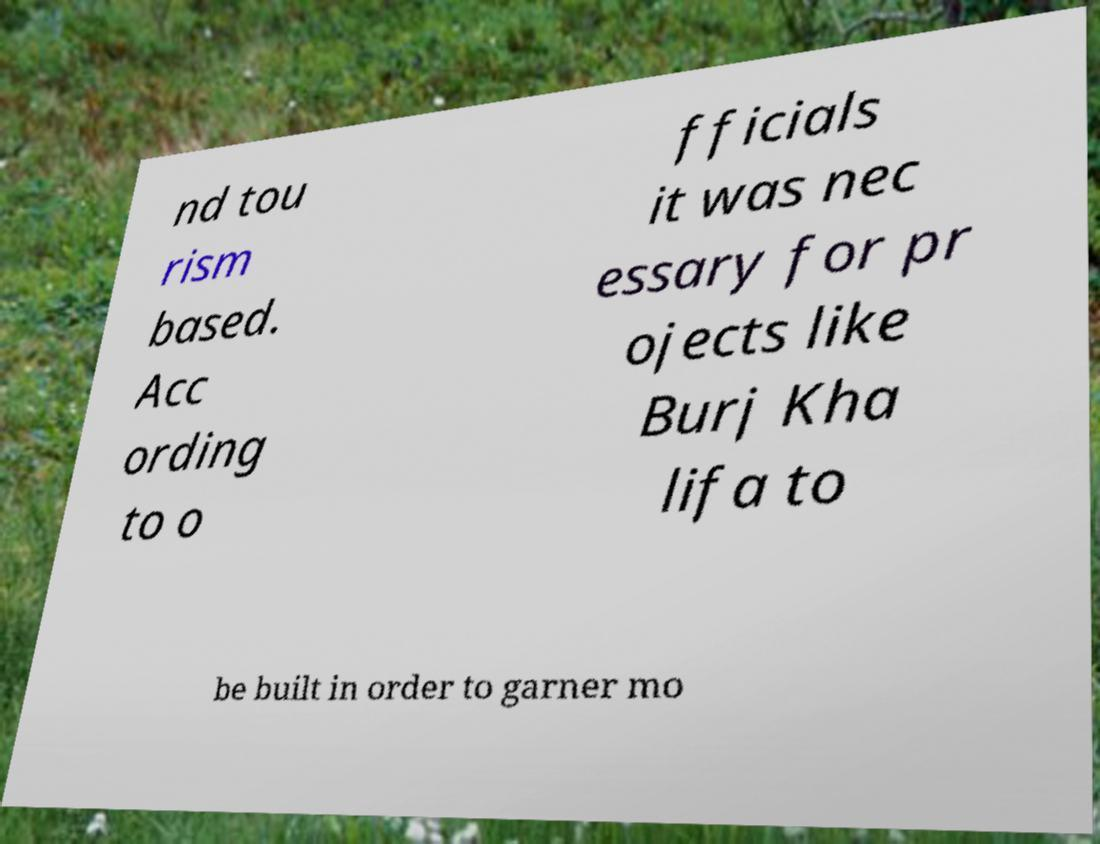Please read and relay the text visible in this image. What does it say? nd tou rism based. Acc ording to o fficials it was nec essary for pr ojects like Burj Kha lifa to be built in order to garner mo 